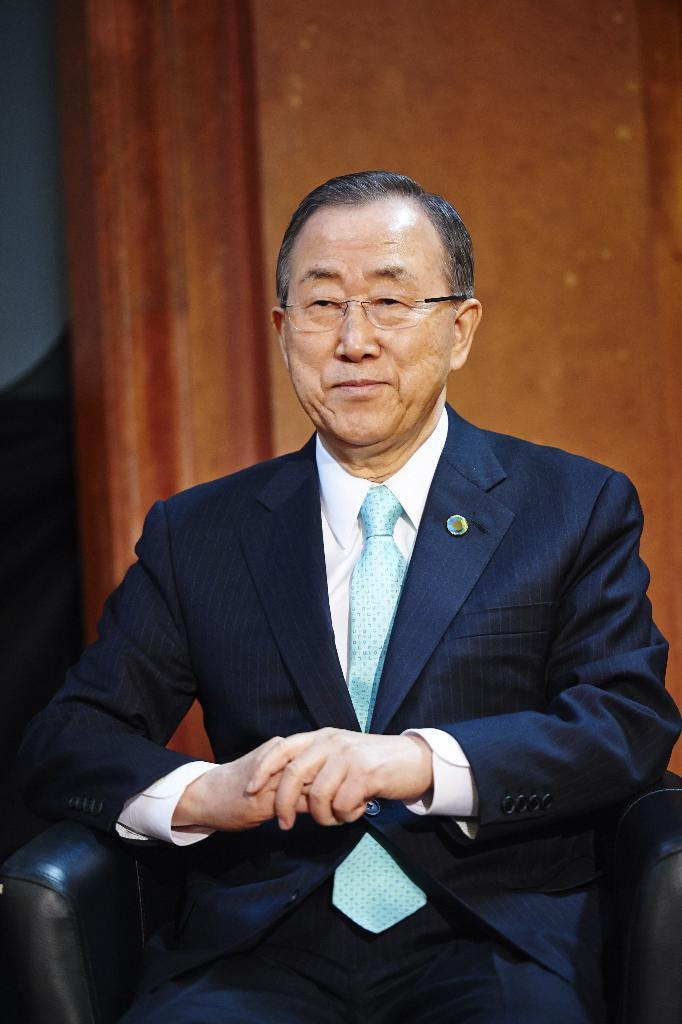What are the persons in the image doing? The persons in the image are sitting on chairs. What can be seen in the background of the image? There is a wall in the background of the image. What type of bike is leaning against the wall in the image? There is no bike present in the image; only persons sitting on chairs and a wall in the background are visible. 